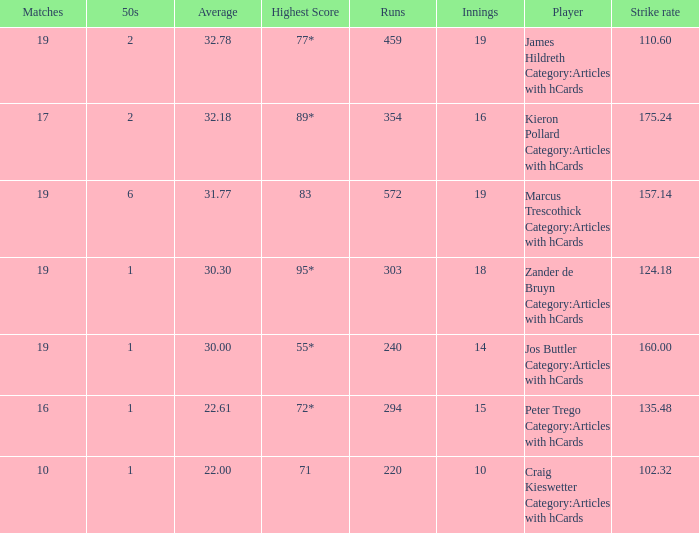How many innings for the player with an average of 22.61? 15.0. 